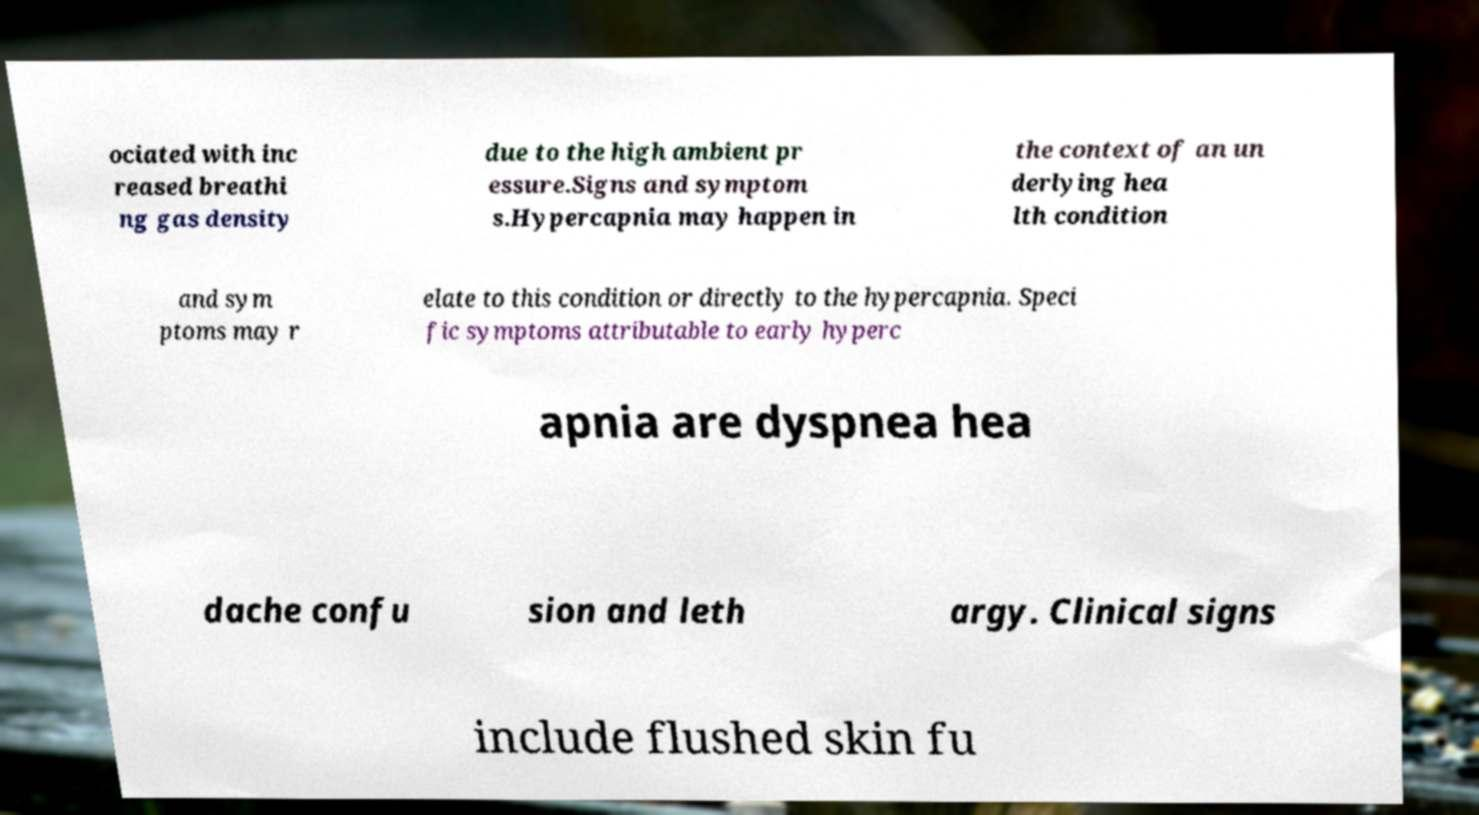There's text embedded in this image that I need extracted. Can you transcribe it verbatim? ociated with inc reased breathi ng gas density due to the high ambient pr essure.Signs and symptom s.Hypercapnia may happen in the context of an un derlying hea lth condition and sym ptoms may r elate to this condition or directly to the hypercapnia. Speci fic symptoms attributable to early hyperc apnia are dyspnea hea dache confu sion and leth argy. Clinical signs include flushed skin fu 